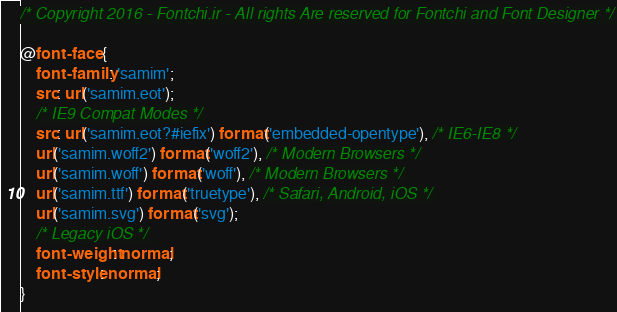Convert code to text. <code><loc_0><loc_0><loc_500><loc_500><_CSS_>/* Copyright 2016 - Fontchi.ir - All rights Are reserved for Fontchi and Font Designer */

@font-face {
    font-family: 'samim';
    src: url('samim.eot');
    /* IE9 Compat Modes */
    src: url('samim.eot?#iefix') format('embedded-opentype'), /* IE6-IE8 */
    url('samim.woff2') format('woff2'), /* Modern Browsers */
    url('samim.woff') format('woff'), /* Modern Browsers */
    url('samim.ttf') format('truetype'), /* Safari, Android, iOS */
    url('samim.svg') format('svg');
    /* Legacy iOS */
    font-weight: normal;
    font-style: normal;
}
</code> 